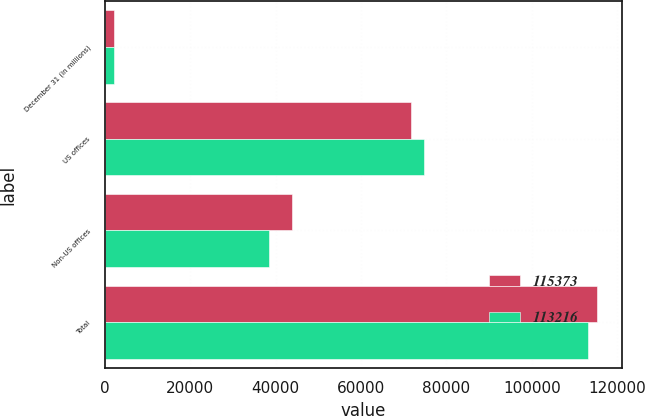<chart> <loc_0><loc_0><loc_500><loc_500><stacked_bar_chart><ecel><fcel>December 31 (in millions)<fcel>US offices<fcel>Non-US offices<fcel>Total<nl><fcel>115373<fcel>2014<fcel>71630<fcel>43743<fcel>115373<nl><fcel>113216<fcel>2013<fcel>74804<fcel>38412<fcel>113216<nl></chart> 